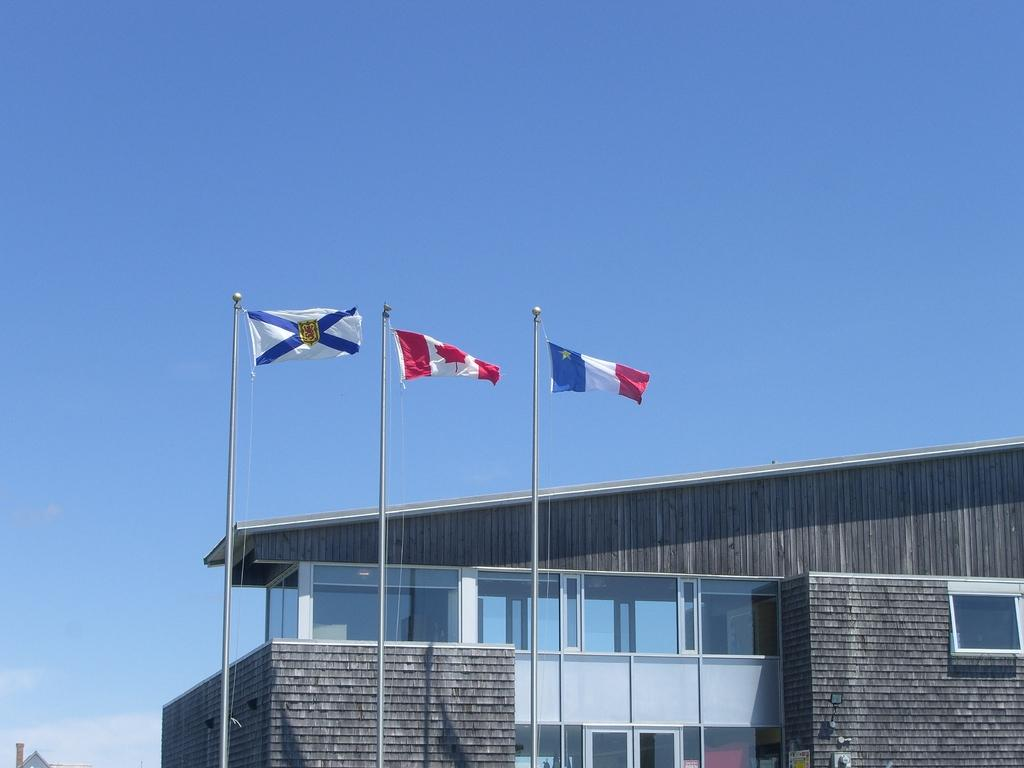How many flags are present in the image? There are three flags in the image. What else can be seen in the image besides the flags? There is a building and other objects in the image. What is visible in the background of the image? The sky is visible in the background of the image. What type of button can be seen on the dog in the image? There is no dog or button present in the image. How does the balance of the flags affect the stability of the building in the image? There is no information about the balance of the flags or their effect on the building in the image. 